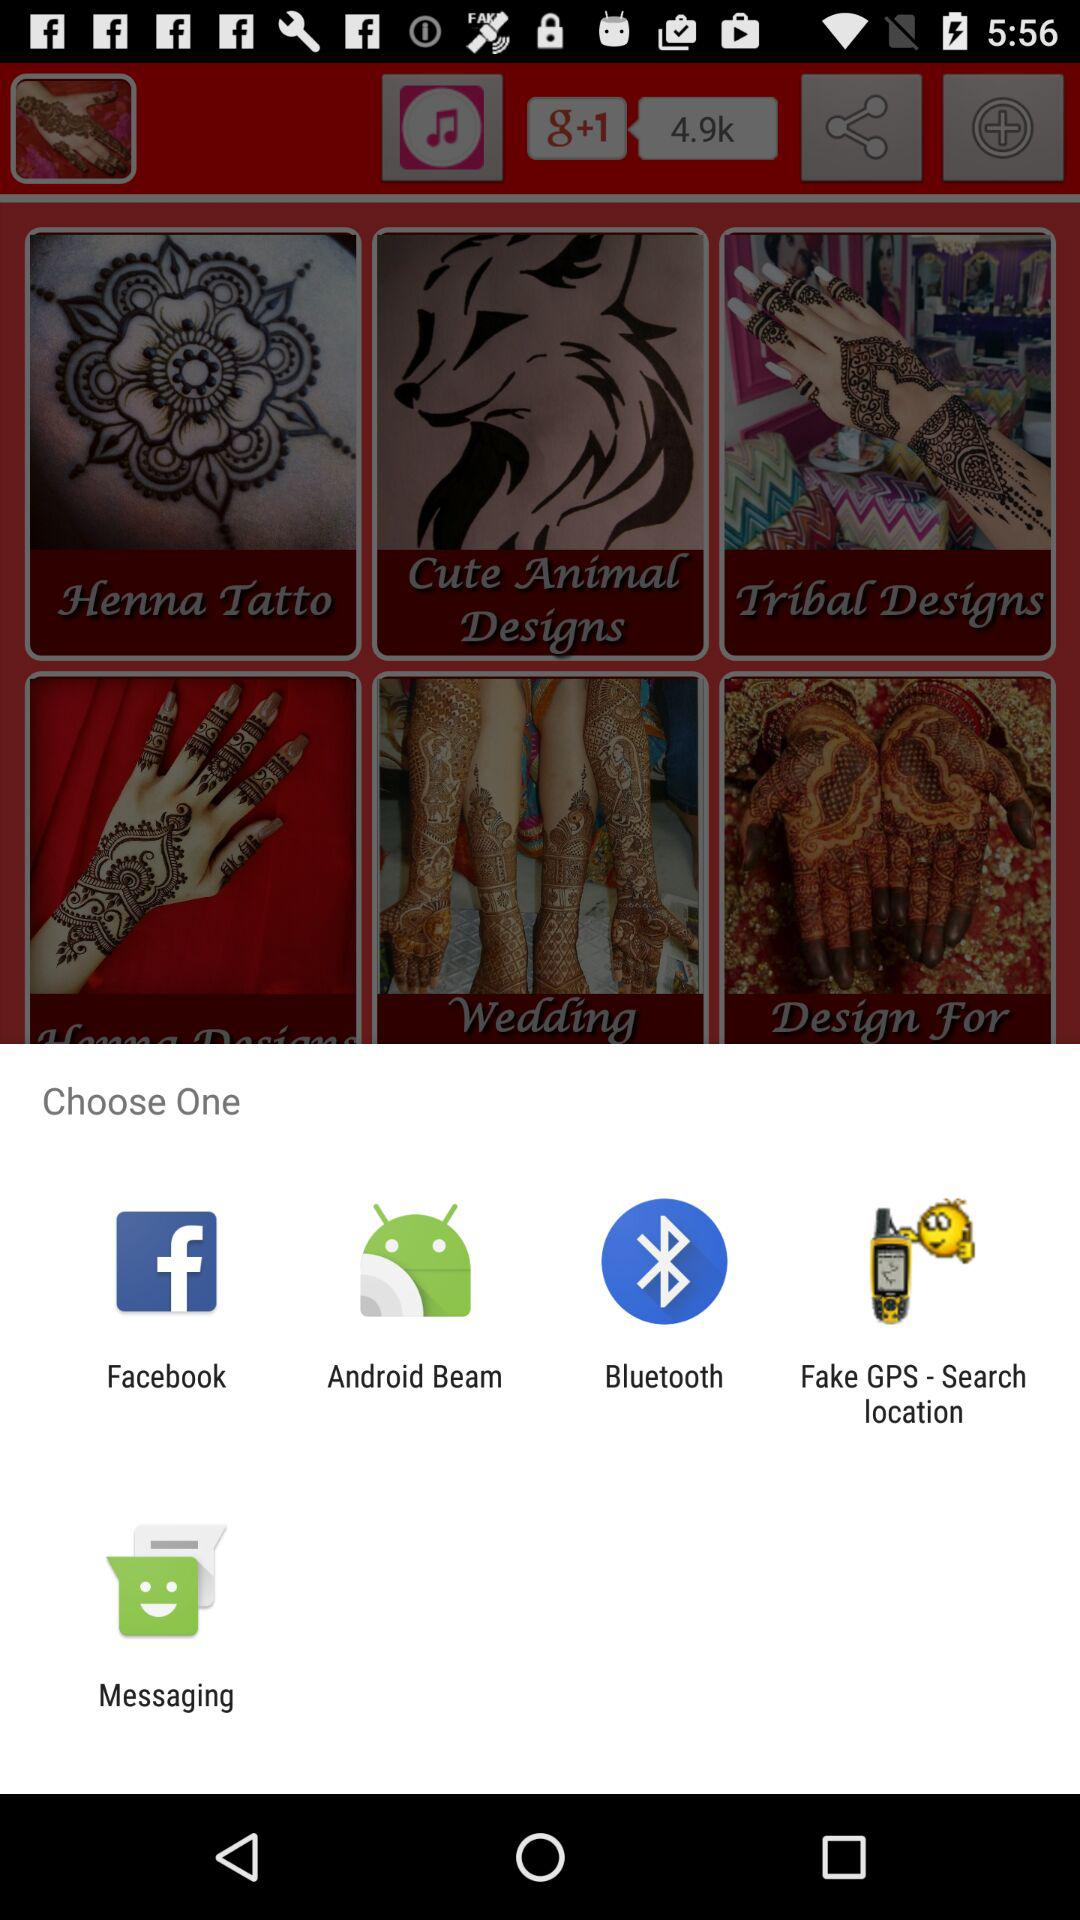Through which app can I share? You can share through "Facebook", "Android Beam", "Bluetooth", "Fake GPS - Search location" and "Messaging". 